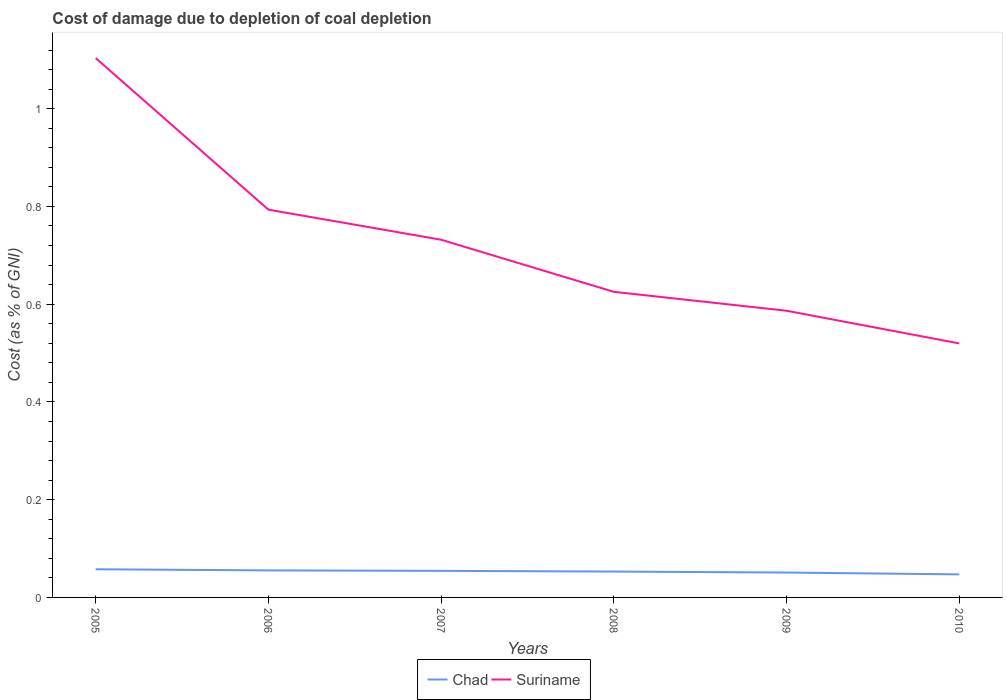How many different coloured lines are there?
Offer a terse response. 2. Does the line corresponding to Chad intersect with the line corresponding to Suriname?
Provide a short and direct response. No. Across all years, what is the maximum cost of damage caused due to coal depletion in Suriname?
Give a very brief answer. 0.52. What is the total cost of damage caused due to coal depletion in Chad in the graph?
Your answer should be compact. 0. What is the difference between the highest and the second highest cost of damage caused due to coal depletion in Chad?
Your response must be concise. 0.01. What is the difference between the highest and the lowest cost of damage caused due to coal depletion in Chad?
Your answer should be compact. 3. How many years are there in the graph?
Keep it short and to the point. 6. Are the values on the major ticks of Y-axis written in scientific E-notation?
Provide a succinct answer. No. Where does the legend appear in the graph?
Provide a succinct answer. Bottom center. What is the title of the graph?
Provide a succinct answer. Cost of damage due to depletion of coal depletion. Does "Bahamas" appear as one of the legend labels in the graph?
Ensure brevity in your answer.  No. What is the label or title of the Y-axis?
Ensure brevity in your answer.  Cost (as % of GNI). What is the Cost (as % of GNI) in Chad in 2005?
Keep it short and to the point. 0.06. What is the Cost (as % of GNI) of Suriname in 2005?
Provide a short and direct response. 1.1. What is the Cost (as % of GNI) of Chad in 2006?
Offer a terse response. 0.06. What is the Cost (as % of GNI) in Suriname in 2006?
Provide a succinct answer. 0.79. What is the Cost (as % of GNI) in Chad in 2007?
Make the answer very short. 0.05. What is the Cost (as % of GNI) in Suriname in 2007?
Give a very brief answer. 0.73. What is the Cost (as % of GNI) of Chad in 2008?
Your answer should be compact. 0.05. What is the Cost (as % of GNI) of Suriname in 2008?
Your answer should be compact. 0.63. What is the Cost (as % of GNI) of Chad in 2009?
Offer a very short reply. 0.05. What is the Cost (as % of GNI) in Suriname in 2009?
Your answer should be very brief. 0.59. What is the Cost (as % of GNI) of Chad in 2010?
Make the answer very short. 0.05. What is the Cost (as % of GNI) of Suriname in 2010?
Give a very brief answer. 0.52. Across all years, what is the maximum Cost (as % of GNI) in Chad?
Make the answer very short. 0.06. Across all years, what is the maximum Cost (as % of GNI) in Suriname?
Offer a very short reply. 1.1. Across all years, what is the minimum Cost (as % of GNI) in Chad?
Provide a short and direct response. 0.05. Across all years, what is the minimum Cost (as % of GNI) of Suriname?
Keep it short and to the point. 0.52. What is the total Cost (as % of GNI) of Chad in the graph?
Your answer should be compact. 0.32. What is the total Cost (as % of GNI) of Suriname in the graph?
Your answer should be very brief. 4.36. What is the difference between the Cost (as % of GNI) in Chad in 2005 and that in 2006?
Make the answer very short. 0. What is the difference between the Cost (as % of GNI) of Suriname in 2005 and that in 2006?
Keep it short and to the point. 0.31. What is the difference between the Cost (as % of GNI) of Chad in 2005 and that in 2007?
Keep it short and to the point. 0. What is the difference between the Cost (as % of GNI) of Suriname in 2005 and that in 2007?
Your answer should be very brief. 0.37. What is the difference between the Cost (as % of GNI) in Chad in 2005 and that in 2008?
Offer a terse response. 0. What is the difference between the Cost (as % of GNI) of Suriname in 2005 and that in 2008?
Ensure brevity in your answer.  0.48. What is the difference between the Cost (as % of GNI) of Chad in 2005 and that in 2009?
Give a very brief answer. 0.01. What is the difference between the Cost (as % of GNI) of Suriname in 2005 and that in 2009?
Your response must be concise. 0.52. What is the difference between the Cost (as % of GNI) of Chad in 2005 and that in 2010?
Ensure brevity in your answer.  0.01. What is the difference between the Cost (as % of GNI) of Suriname in 2005 and that in 2010?
Offer a very short reply. 0.58. What is the difference between the Cost (as % of GNI) of Chad in 2006 and that in 2007?
Your answer should be very brief. 0. What is the difference between the Cost (as % of GNI) of Suriname in 2006 and that in 2007?
Give a very brief answer. 0.06. What is the difference between the Cost (as % of GNI) in Chad in 2006 and that in 2008?
Your answer should be very brief. 0. What is the difference between the Cost (as % of GNI) in Suriname in 2006 and that in 2008?
Provide a succinct answer. 0.17. What is the difference between the Cost (as % of GNI) of Chad in 2006 and that in 2009?
Your answer should be very brief. 0. What is the difference between the Cost (as % of GNI) of Suriname in 2006 and that in 2009?
Keep it short and to the point. 0.21. What is the difference between the Cost (as % of GNI) in Chad in 2006 and that in 2010?
Provide a succinct answer. 0.01. What is the difference between the Cost (as % of GNI) in Suriname in 2006 and that in 2010?
Provide a succinct answer. 0.27. What is the difference between the Cost (as % of GNI) in Chad in 2007 and that in 2008?
Your answer should be very brief. 0. What is the difference between the Cost (as % of GNI) in Suriname in 2007 and that in 2008?
Your response must be concise. 0.11. What is the difference between the Cost (as % of GNI) of Chad in 2007 and that in 2009?
Offer a very short reply. 0. What is the difference between the Cost (as % of GNI) of Suriname in 2007 and that in 2009?
Keep it short and to the point. 0.15. What is the difference between the Cost (as % of GNI) of Chad in 2007 and that in 2010?
Ensure brevity in your answer.  0.01. What is the difference between the Cost (as % of GNI) in Suriname in 2007 and that in 2010?
Keep it short and to the point. 0.21. What is the difference between the Cost (as % of GNI) in Chad in 2008 and that in 2009?
Your response must be concise. 0. What is the difference between the Cost (as % of GNI) of Suriname in 2008 and that in 2009?
Make the answer very short. 0.04. What is the difference between the Cost (as % of GNI) in Chad in 2008 and that in 2010?
Provide a short and direct response. 0.01. What is the difference between the Cost (as % of GNI) of Suriname in 2008 and that in 2010?
Provide a short and direct response. 0.11. What is the difference between the Cost (as % of GNI) in Chad in 2009 and that in 2010?
Make the answer very short. 0. What is the difference between the Cost (as % of GNI) in Suriname in 2009 and that in 2010?
Your answer should be very brief. 0.07. What is the difference between the Cost (as % of GNI) in Chad in 2005 and the Cost (as % of GNI) in Suriname in 2006?
Keep it short and to the point. -0.74. What is the difference between the Cost (as % of GNI) in Chad in 2005 and the Cost (as % of GNI) in Suriname in 2007?
Ensure brevity in your answer.  -0.67. What is the difference between the Cost (as % of GNI) of Chad in 2005 and the Cost (as % of GNI) of Suriname in 2008?
Provide a short and direct response. -0.57. What is the difference between the Cost (as % of GNI) of Chad in 2005 and the Cost (as % of GNI) of Suriname in 2009?
Make the answer very short. -0.53. What is the difference between the Cost (as % of GNI) in Chad in 2005 and the Cost (as % of GNI) in Suriname in 2010?
Your answer should be compact. -0.46. What is the difference between the Cost (as % of GNI) in Chad in 2006 and the Cost (as % of GNI) in Suriname in 2007?
Offer a very short reply. -0.68. What is the difference between the Cost (as % of GNI) of Chad in 2006 and the Cost (as % of GNI) of Suriname in 2008?
Offer a very short reply. -0.57. What is the difference between the Cost (as % of GNI) of Chad in 2006 and the Cost (as % of GNI) of Suriname in 2009?
Offer a very short reply. -0.53. What is the difference between the Cost (as % of GNI) in Chad in 2006 and the Cost (as % of GNI) in Suriname in 2010?
Give a very brief answer. -0.46. What is the difference between the Cost (as % of GNI) of Chad in 2007 and the Cost (as % of GNI) of Suriname in 2008?
Your answer should be compact. -0.57. What is the difference between the Cost (as % of GNI) of Chad in 2007 and the Cost (as % of GNI) of Suriname in 2009?
Your answer should be compact. -0.53. What is the difference between the Cost (as % of GNI) in Chad in 2007 and the Cost (as % of GNI) in Suriname in 2010?
Provide a short and direct response. -0.47. What is the difference between the Cost (as % of GNI) of Chad in 2008 and the Cost (as % of GNI) of Suriname in 2009?
Your response must be concise. -0.53. What is the difference between the Cost (as % of GNI) in Chad in 2008 and the Cost (as % of GNI) in Suriname in 2010?
Give a very brief answer. -0.47. What is the difference between the Cost (as % of GNI) of Chad in 2009 and the Cost (as % of GNI) of Suriname in 2010?
Your answer should be very brief. -0.47. What is the average Cost (as % of GNI) of Chad per year?
Your answer should be very brief. 0.05. What is the average Cost (as % of GNI) in Suriname per year?
Ensure brevity in your answer.  0.73. In the year 2005, what is the difference between the Cost (as % of GNI) of Chad and Cost (as % of GNI) of Suriname?
Offer a terse response. -1.05. In the year 2006, what is the difference between the Cost (as % of GNI) in Chad and Cost (as % of GNI) in Suriname?
Provide a succinct answer. -0.74. In the year 2007, what is the difference between the Cost (as % of GNI) of Chad and Cost (as % of GNI) of Suriname?
Your response must be concise. -0.68. In the year 2008, what is the difference between the Cost (as % of GNI) of Chad and Cost (as % of GNI) of Suriname?
Give a very brief answer. -0.57. In the year 2009, what is the difference between the Cost (as % of GNI) in Chad and Cost (as % of GNI) in Suriname?
Provide a short and direct response. -0.54. In the year 2010, what is the difference between the Cost (as % of GNI) in Chad and Cost (as % of GNI) in Suriname?
Your response must be concise. -0.47. What is the ratio of the Cost (as % of GNI) in Chad in 2005 to that in 2006?
Give a very brief answer. 1.04. What is the ratio of the Cost (as % of GNI) of Suriname in 2005 to that in 2006?
Your answer should be compact. 1.39. What is the ratio of the Cost (as % of GNI) in Chad in 2005 to that in 2007?
Make the answer very short. 1.06. What is the ratio of the Cost (as % of GNI) of Suriname in 2005 to that in 2007?
Keep it short and to the point. 1.51. What is the ratio of the Cost (as % of GNI) of Chad in 2005 to that in 2008?
Give a very brief answer. 1.09. What is the ratio of the Cost (as % of GNI) in Suriname in 2005 to that in 2008?
Ensure brevity in your answer.  1.76. What is the ratio of the Cost (as % of GNI) in Chad in 2005 to that in 2009?
Provide a short and direct response. 1.13. What is the ratio of the Cost (as % of GNI) of Suriname in 2005 to that in 2009?
Give a very brief answer. 1.88. What is the ratio of the Cost (as % of GNI) in Chad in 2005 to that in 2010?
Keep it short and to the point. 1.22. What is the ratio of the Cost (as % of GNI) in Suriname in 2005 to that in 2010?
Provide a succinct answer. 2.12. What is the ratio of the Cost (as % of GNI) of Chad in 2006 to that in 2007?
Give a very brief answer. 1.02. What is the ratio of the Cost (as % of GNI) of Suriname in 2006 to that in 2007?
Your answer should be compact. 1.08. What is the ratio of the Cost (as % of GNI) in Chad in 2006 to that in 2008?
Your answer should be compact. 1.05. What is the ratio of the Cost (as % of GNI) of Suriname in 2006 to that in 2008?
Provide a succinct answer. 1.27. What is the ratio of the Cost (as % of GNI) of Chad in 2006 to that in 2009?
Your response must be concise. 1.09. What is the ratio of the Cost (as % of GNI) of Suriname in 2006 to that in 2009?
Provide a short and direct response. 1.35. What is the ratio of the Cost (as % of GNI) in Chad in 2006 to that in 2010?
Your response must be concise. 1.17. What is the ratio of the Cost (as % of GNI) in Suriname in 2006 to that in 2010?
Ensure brevity in your answer.  1.53. What is the ratio of the Cost (as % of GNI) in Chad in 2007 to that in 2008?
Keep it short and to the point. 1.03. What is the ratio of the Cost (as % of GNI) of Suriname in 2007 to that in 2008?
Provide a short and direct response. 1.17. What is the ratio of the Cost (as % of GNI) of Chad in 2007 to that in 2009?
Ensure brevity in your answer.  1.07. What is the ratio of the Cost (as % of GNI) of Suriname in 2007 to that in 2009?
Give a very brief answer. 1.25. What is the ratio of the Cost (as % of GNI) of Chad in 2007 to that in 2010?
Offer a very short reply. 1.15. What is the ratio of the Cost (as % of GNI) in Suriname in 2007 to that in 2010?
Your response must be concise. 1.41. What is the ratio of the Cost (as % of GNI) of Chad in 2008 to that in 2009?
Offer a terse response. 1.04. What is the ratio of the Cost (as % of GNI) of Suriname in 2008 to that in 2009?
Your response must be concise. 1.07. What is the ratio of the Cost (as % of GNI) of Chad in 2008 to that in 2010?
Offer a terse response. 1.12. What is the ratio of the Cost (as % of GNI) of Suriname in 2008 to that in 2010?
Provide a succinct answer. 1.2. What is the ratio of the Cost (as % of GNI) of Chad in 2009 to that in 2010?
Provide a succinct answer. 1.08. What is the ratio of the Cost (as % of GNI) in Suriname in 2009 to that in 2010?
Provide a short and direct response. 1.13. What is the difference between the highest and the second highest Cost (as % of GNI) in Chad?
Your answer should be compact. 0. What is the difference between the highest and the second highest Cost (as % of GNI) in Suriname?
Offer a very short reply. 0.31. What is the difference between the highest and the lowest Cost (as % of GNI) in Chad?
Offer a terse response. 0.01. What is the difference between the highest and the lowest Cost (as % of GNI) of Suriname?
Provide a short and direct response. 0.58. 